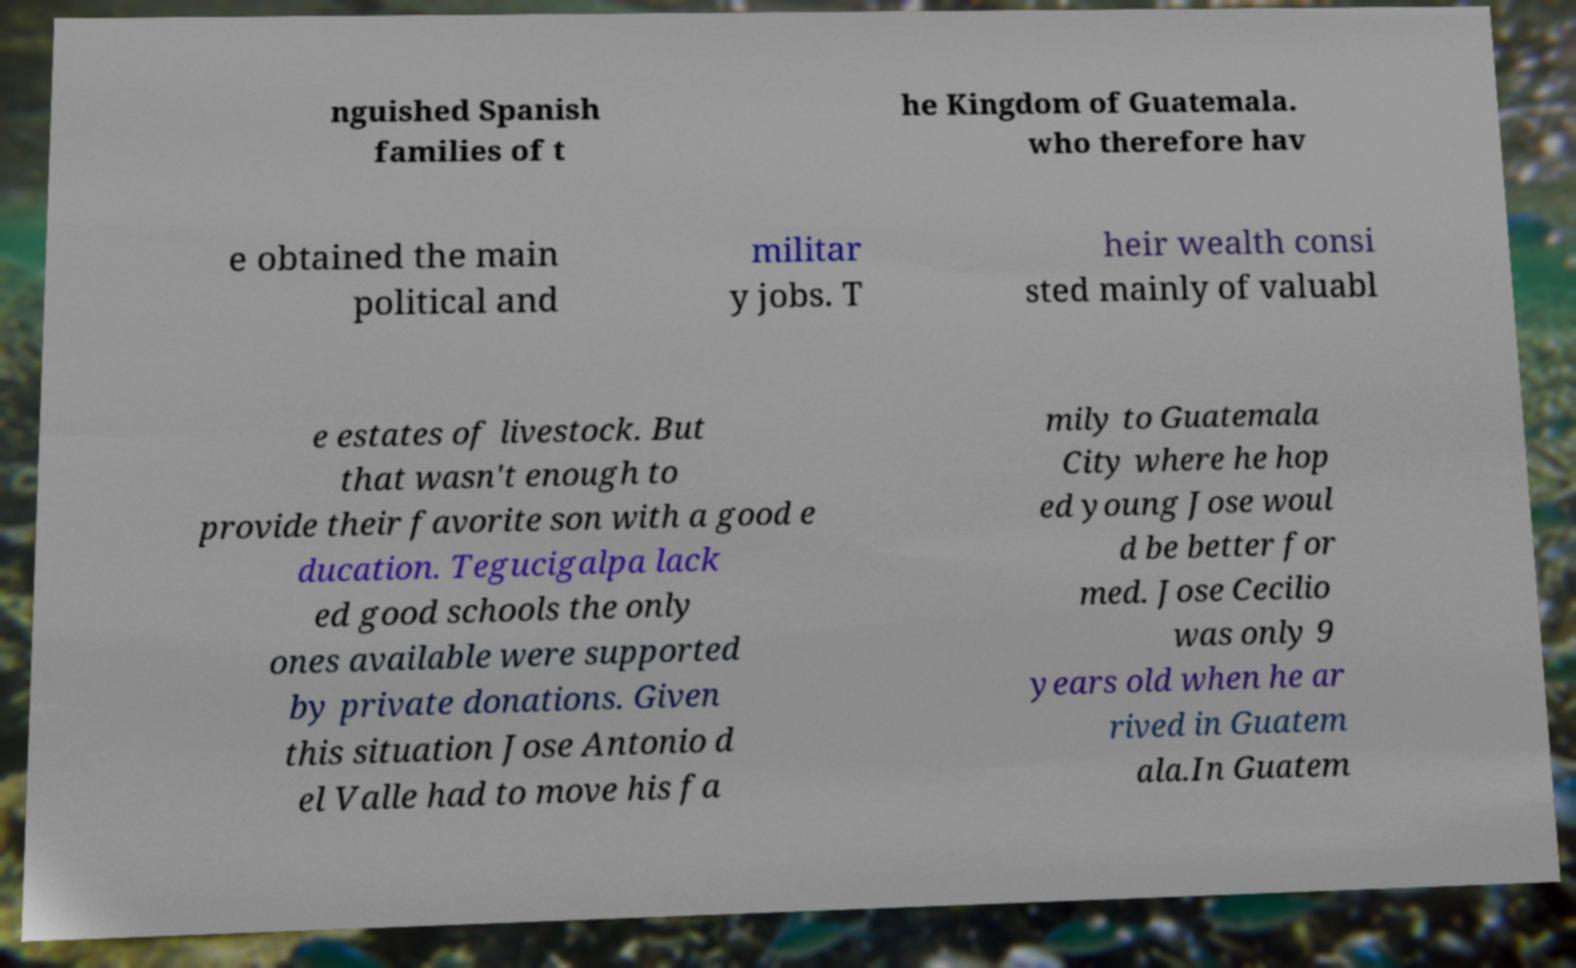I need the written content from this picture converted into text. Can you do that? nguished Spanish families of t he Kingdom of Guatemala. who therefore hav e obtained the main political and militar y jobs. T heir wealth consi sted mainly of valuabl e estates of livestock. But that wasn't enough to provide their favorite son with a good e ducation. Tegucigalpa lack ed good schools the only ones available were supported by private donations. Given this situation Jose Antonio d el Valle had to move his fa mily to Guatemala City where he hop ed young Jose woul d be better for med. Jose Cecilio was only 9 years old when he ar rived in Guatem ala.In Guatem 